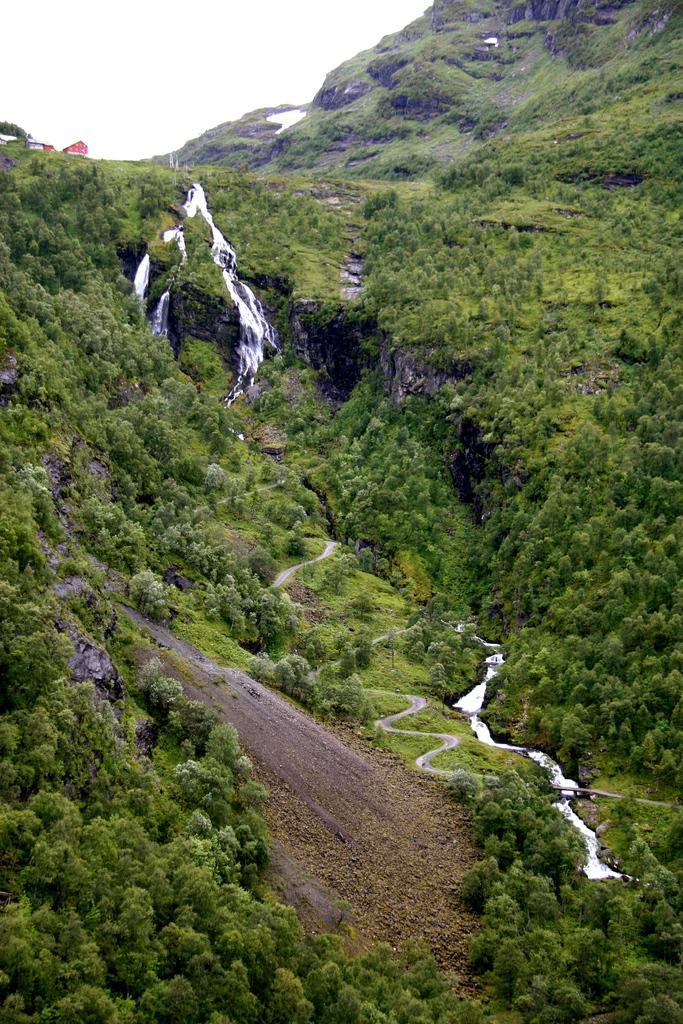Please provide a concise description of this image. At the bottom, we see the trees and the water is flowing. In the middle, we see the waterfalls and trees. On the left side, it looks like a hut, which is in red color. There are hills and the trees in the background. At the top, we see the sky. 